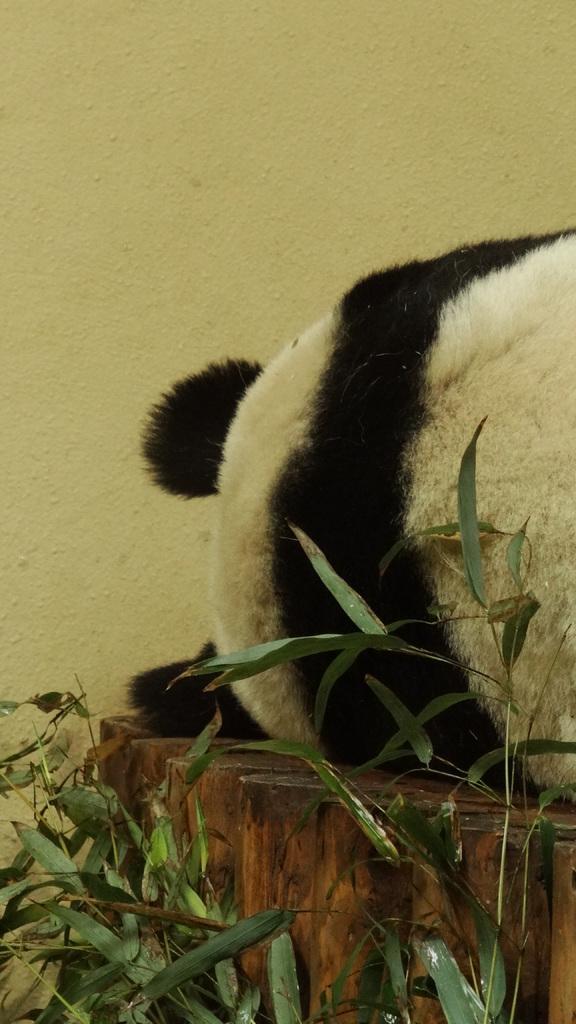Please provide a concise description of this image. In the image there is a panda laying on wooden surface, beside the panda there are leaves of plants. 